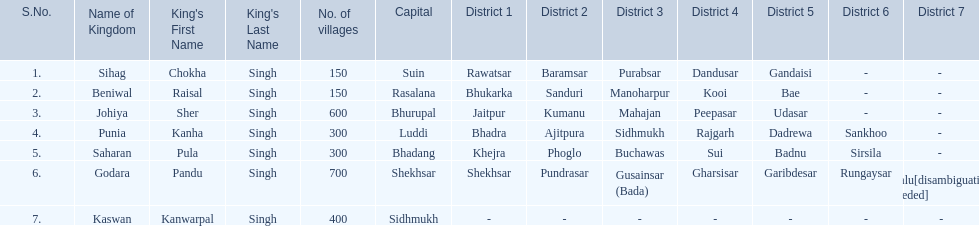What is the most amount of villages in a kingdom? 700. What is the second most amount of villages in a kingdom? 600. What kingdom has 600 villages? Johiya. Could you parse the entire table as a dict? {'header': ['S.No.', 'Name of Kingdom', "King's First Name", "King's Last Name", 'No. of villages', 'Capital', 'District 1', 'District 2', 'District 3', 'District 4', 'District 5', 'District 6', 'District 7'], 'rows': [['1.', 'Sihag', 'Chokha', 'Singh', '150', 'Suin', 'Rawatsar', 'Baramsar', 'Purabsar', 'Dandusar', 'Gandaisi', '-', '- '], ['2.', 'Beniwal', 'Raisal', 'Singh', '150', 'Rasalana', 'Bhukarka', 'Sanduri', 'Manoharpur', 'Kooi', 'Bae', '-', '- '], ['3.', 'Johiya', 'Sher', 'Singh', '600', 'Bhurupal', 'Jaitpur', 'Kumanu', 'Mahajan', 'Peepasar', 'Udasar', '-', '- '], ['4.', 'Punia', 'Kanha', 'Singh', '300', 'Luddi', 'Bhadra', 'Ajitpura', 'Sidhmukh', 'Rajgarh', 'Dadrewa', 'Sankhoo', '- '], ['5.', 'Saharan', 'Pula', 'Singh', '300', 'Bhadang', 'Khejra', 'Phoglo', 'Buchawas', 'Sui', 'Badnu', 'Sirsila', '- '], ['6.', 'Godara', 'Pandu', 'Singh', '700', 'Shekhsar', 'Shekhsar', 'Pundrasar', 'Gusainsar (Bada)', 'Gharsisar', 'Garibdesar', 'Rungaysar', 'Kalu[disambiguation needed]'], ['7.', 'Kaswan', 'Kanwarpal', 'Singh', '400', 'Sidhmukh', '-', '-', '-', '-', '-', '-', '-']]} 